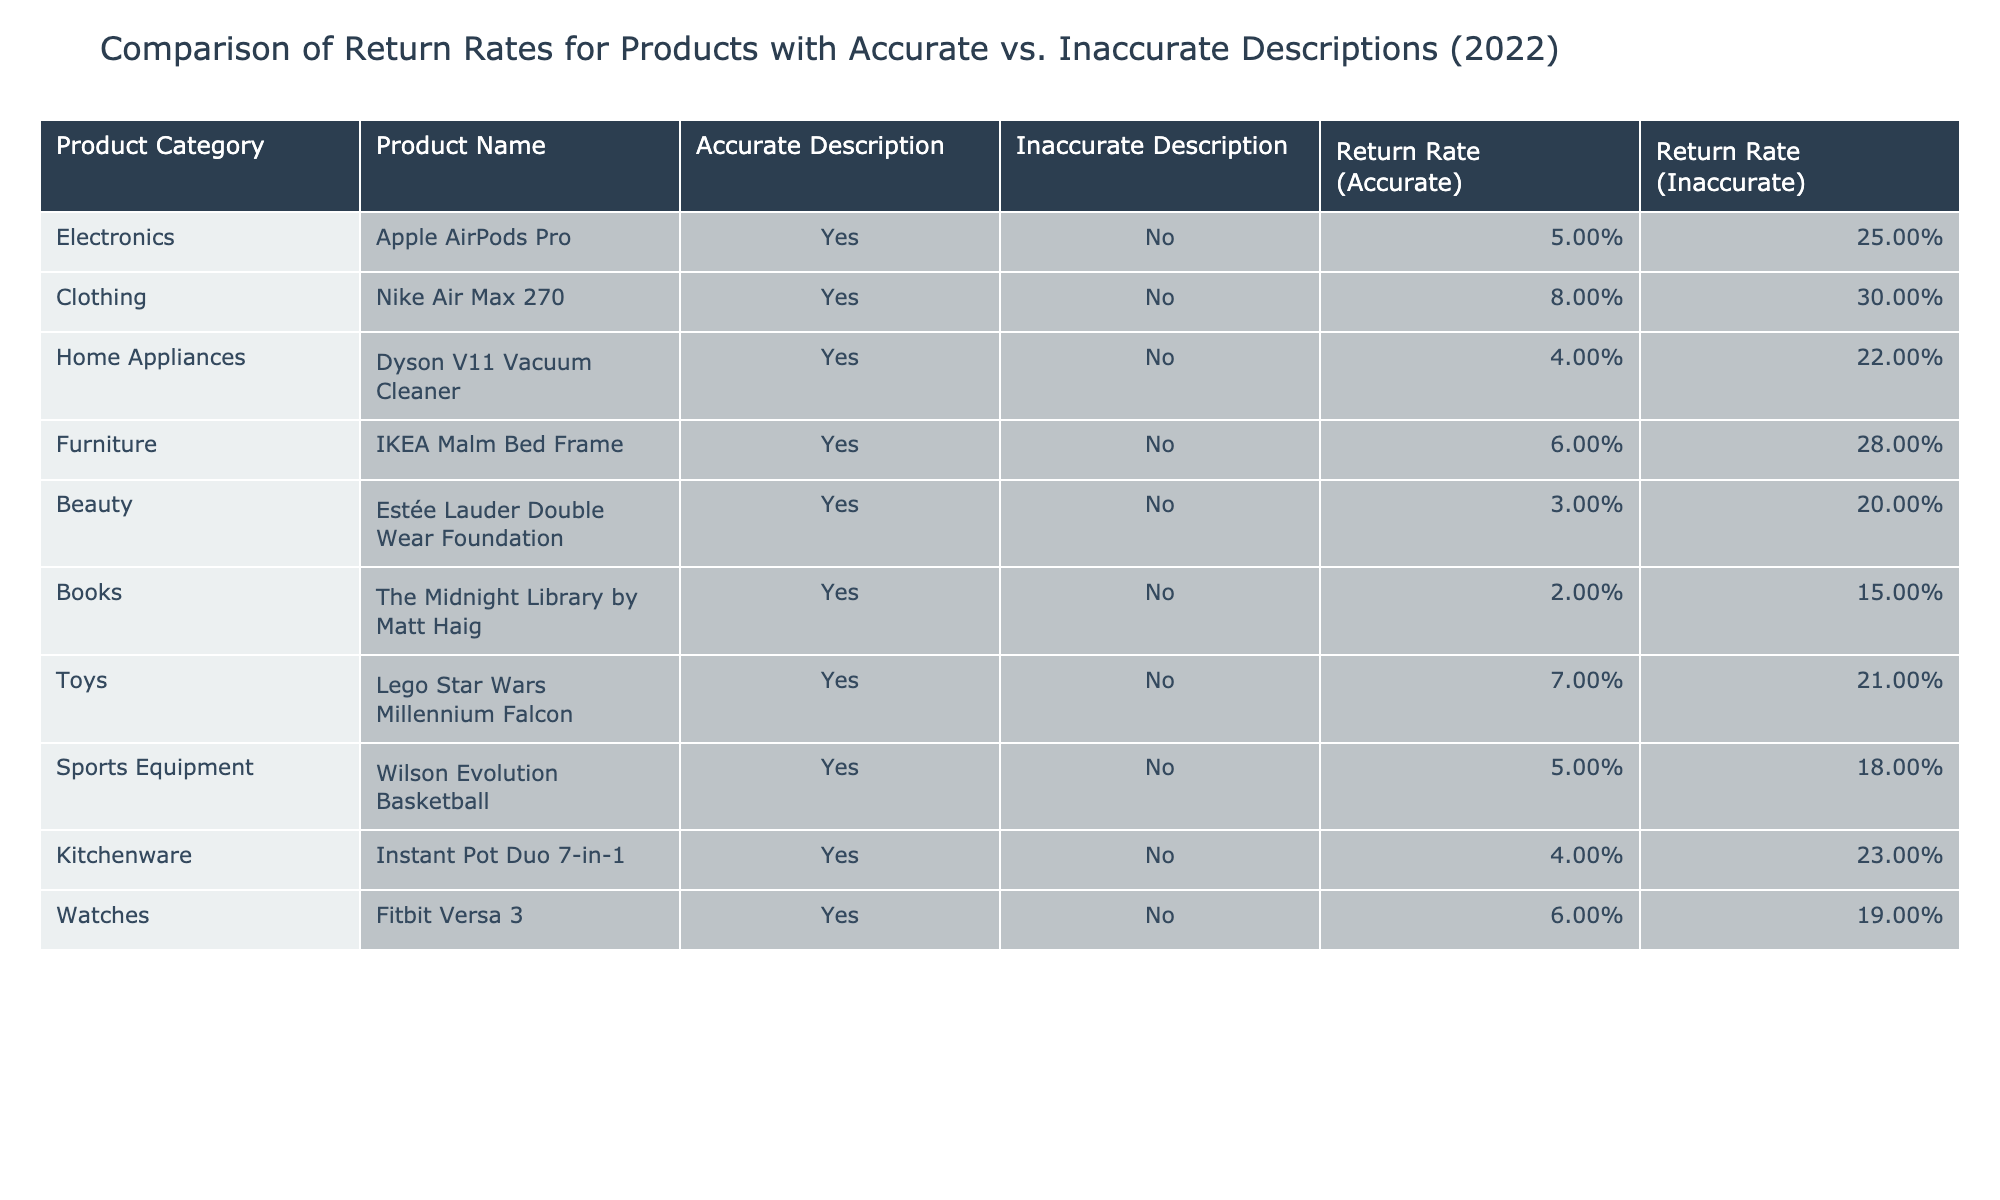What is the return rate for the Fitbit Versa 3 with an inaccurate description? The table lists the return rate for the Fitbit Versa 3 under the "Return Rate (Inaccurate)" column. According to the table, the return rate for the Fitbit Versa 3 with an inaccurate description is 19%.
Answer: 19% What is the return rate difference for the Nike Air Max 270 between accurate and inaccurate descriptions? To find the return rate difference for the Nike Air Max 270, we subtract the return rate for an accurate description (8%) from the return rate for an inaccurate description (30%). Thus, the difference is 30% - 8% = 22%.
Answer: 22% Which product has the highest return rate when the description is inaccurate? The table shows various products with their respective return rates for inaccurate descriptions. The highest return rate listed is 30% for the Nike Air Max 270.
Answer: Nike Air Max 270 Are there any products with a return rate of less than 5% when accurately described? By scanning the "Return Rate (Accurate)" column in the table, we can see that the return rates for all products listed (5%, 8%, 4%, 6%, 3%, 2%, 7%, 5%, 4%, 6%) are 5% or higher. Therefore, there are no products with a return rate of less than 5% when accurately described.
Answer: No What is the average return rate for products with accurate descriptions? First, we list the return rates for accurate descriptions from the table: 5%, 8%, 4%, 6%, 3%, 2%, 7%, 5%, 4%, 6%. Next, we convert these percentages into decimal form: (0.05, 0.08, 0.04, 0.06, 0.03, 0.02, 0.07, 0.05, 0.04, 0.06). Then, we sum these values to get 0.05 + 0.08 + 0.04 + 0.06 + 0.03 + 0.02 + 0.07 + 0.05 + 0.04 + 0.06 = 0.50. Finally, we divide this sum by the number of products (10) to find the average: 0.50 / 10 = 0.05, which translates back to 5%.
Answer: 5% Which two product categories have the largest difference between accurate and inaccurate return rates? To determine this, we calculate the return rate difference for each product category: for Electronics: 25% - 5% = 20%, for Clothing: 30% - 8% = 22%, for Home Appliances: 22% - 4% = 18%, for Furniture: 28% - 6% = 22%, for Beauty: 20% - 3% = 17%, for Books: 15% - 2% = 13%, for Toys: 21% - 7% = 14%, for Sports Equipment: 18% - 5% = 13%, for Kitchenware: 23% - 4% = 19%, for Watches: 19% - 6% = 13%. The maximum differences (22%) occur in the categories Clothing and Furniture.
Answer: Clothing and Furniture 